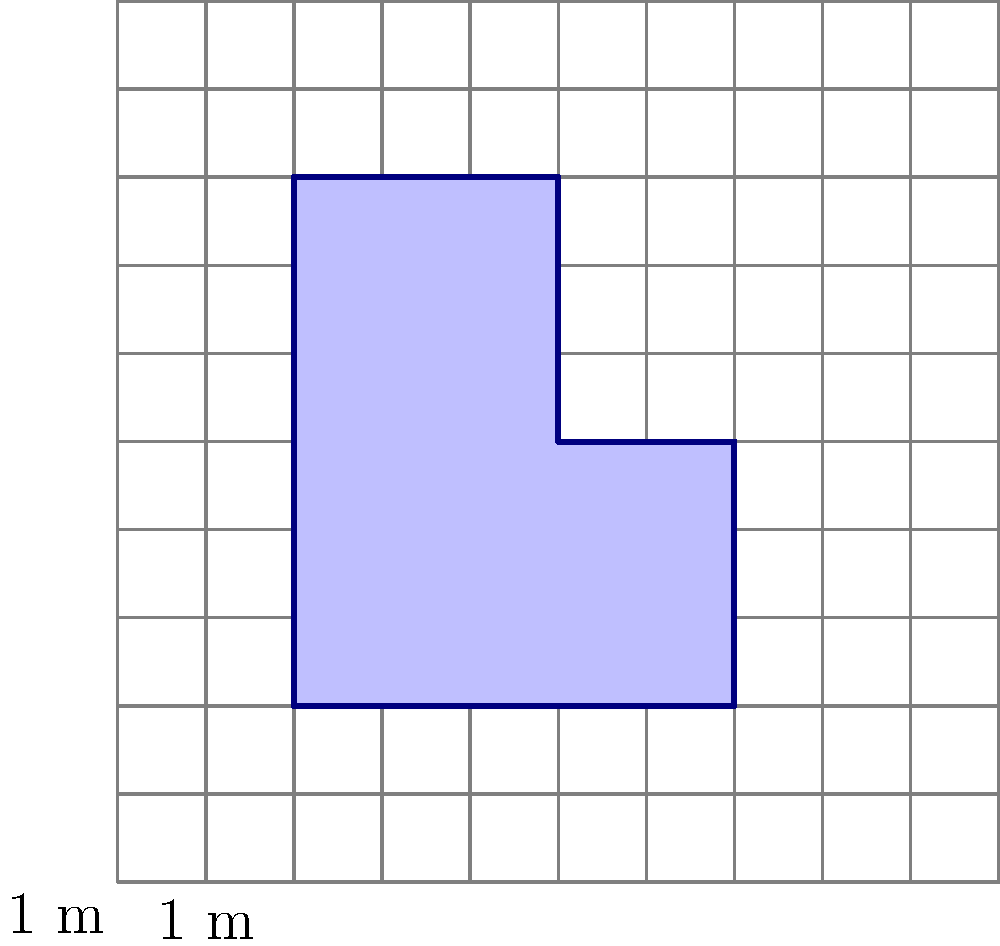As a life coach supporting healthcare professionals, you're designing a relaxation room in a hospital. The room has an irregular shape, as shown in the grid diagram above. Each square in the grid represents 1 square meter. Calculate the total area of the relaxation room in square meters. To calculate the area of the irregularly shaped relaxation room, we'll use the grid method. We'll count the full squares and estimate the partial squares:

1. Count full squares:
   - There are 15 full squares within the room's boundaries.

2. Estimate partial squares:
   - Top-left: approximately 0.5 square
   - Top-right: approximately 0.5 square
   - Bottom-right: approximately 0.5 square

3. Sum up the areas:
   $$\text{Total Area} = \text{Full Squares} + \text{Partial Squares}$$
   $$\text{Total Area} = 15 + (0.5 + 0.5 + 0.5)$$
   $$\text{Total Area} = 15 + 1.5 = 16.5\text{ m}^2$$

Therefore, the total area of the relaxation room is approximately 16.5 square meters.
Answer: $16.5\text{ m}^2$ 